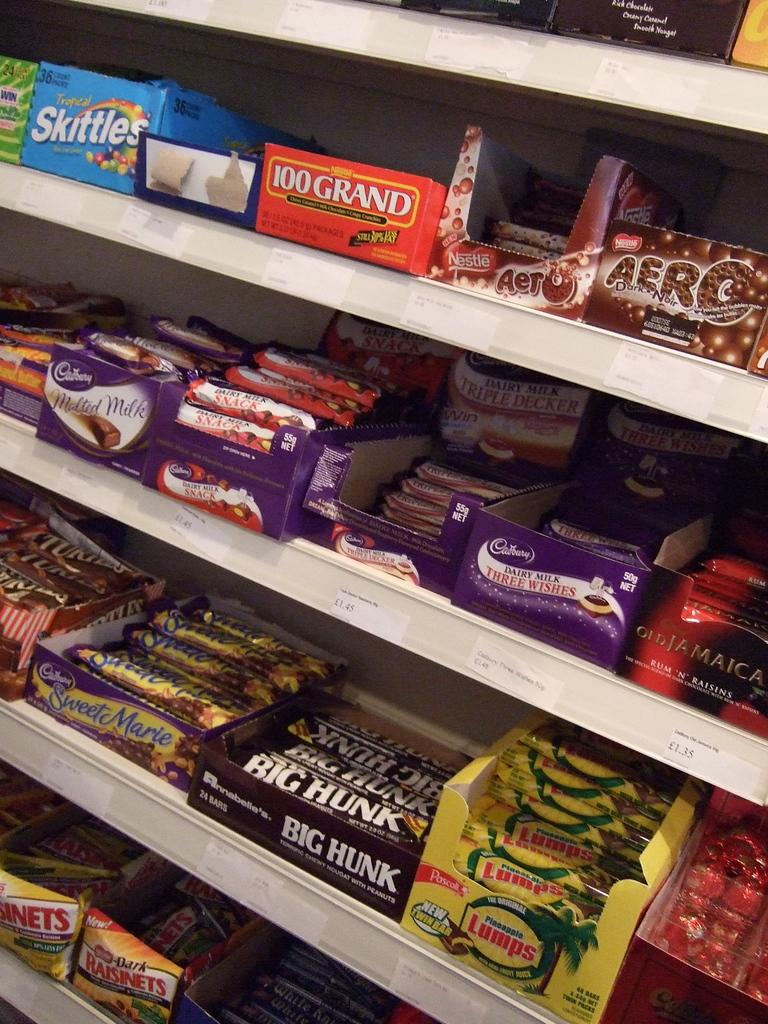<image>
Describe the image concisely. Shelves are full of different candy bars such as 100 Grand and Big Hunk. 